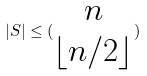<formula> <loc_0><loc_0><loc_500><loc_500>| S | \leq ( \begin{matrix} n \\ \lfloor n / 2 \rfloor \end{matrix} )</formula> 